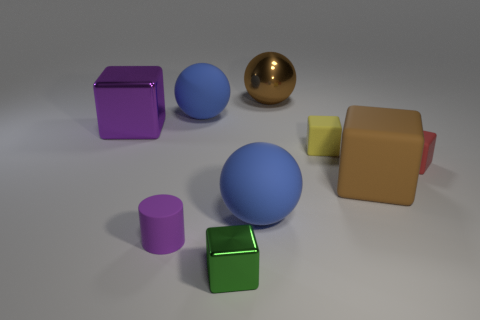The cube that is left of the big brown sphere and in front of the small red rubber cube is made of what material?
Keep it short and to the point. Metal. Is the yellow cube made of the same material as the tiny green cube?
Your response must be concise. No. What is the shape of the tiny purple rubber object?
Your answer should be compact. Cylinder. What number of objects are either tiny yellow blocks or tiny rubber cylinders that are behind the tiny metallic cube?
Make the answer very short. 2. Do the thing left of the purple cylinder and the rubber cylinder have the same color?
Keep it short and to the point. Yes. There is a metal thing that is both behind the green cube and on the right side of the purple shiny object; what is its color?
Your response must be concise. Brown. What material is the big cube that is left of the big brown sphere?
Provide a succinct answer. Metal. The red cube has what size?
Keep it short and to the point. Small. What number of purple objects are cubes or rubber cylinders?
Give a very brief answer. 2. How big is the metallic thing in front of the blue rubber ball in front of the red matte cube?
Give a very brief answer. Small. 